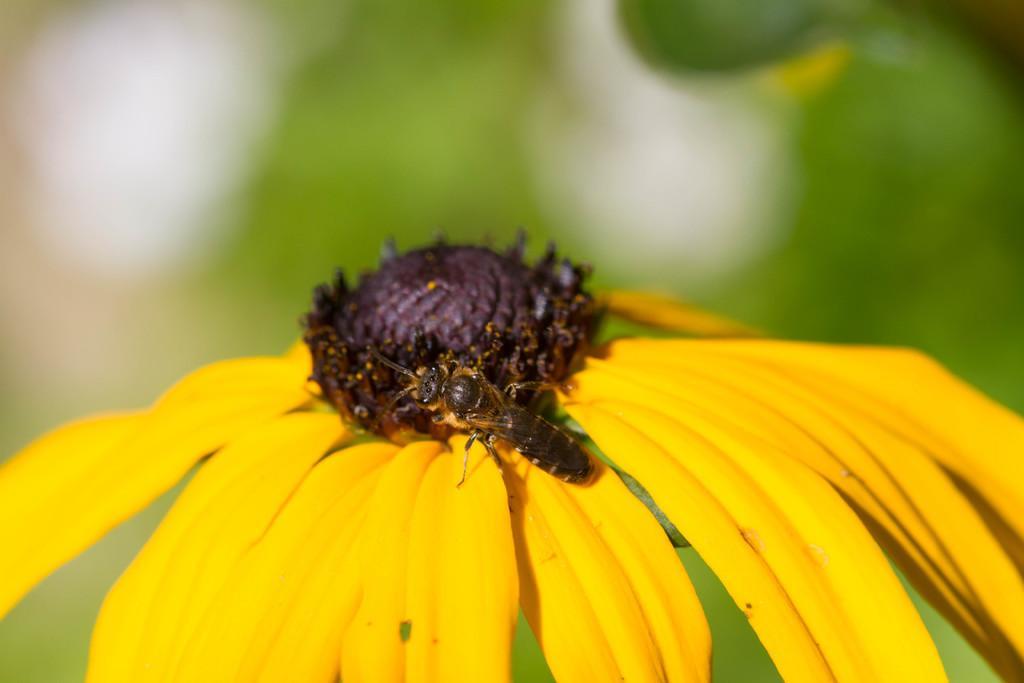How would you summarize this image in a sentence or two? In this picture, there is a sunflower which is in yellow in color. On the flower there is a honey bee. 